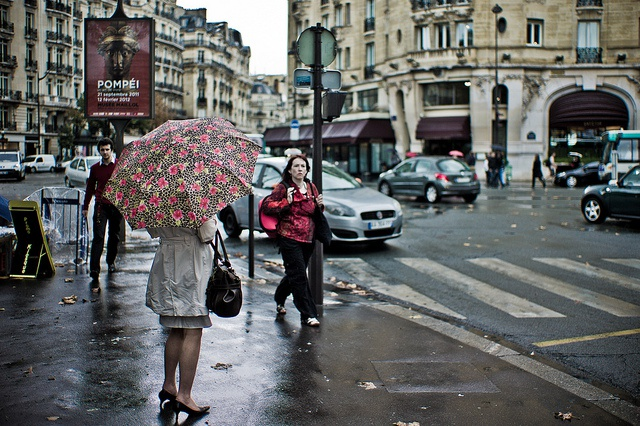Describe the objects in this image and their specific colors. I can see umbrella in black, gray, darkgray, and brown tones, people in black, gray, and darkgray tones, people in black, maroon, darkgray, and lightgray tones, car in black, darkgray, lightgray, and gray tones, and people in black, gray, maroon, and darkgray tones in this image. 